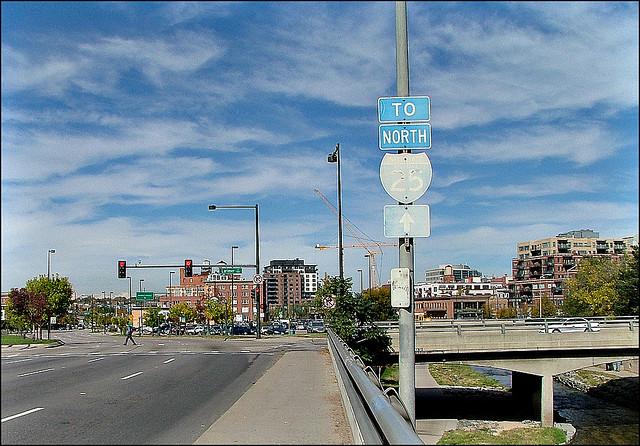Is the sun shining?
Answer briefly. Yes. What type of traffic signal is this?
Be succinct. Stop. What color is the sign?
Short answer required. Blue. Are clouds visible?
Write a very short answer. Yes. How many lanes on the street?
Quick response, please. 4. What light is on the traffic light?
Give a very brief answer. Red. Are there many cars on the street?
Quick response, please. No. 